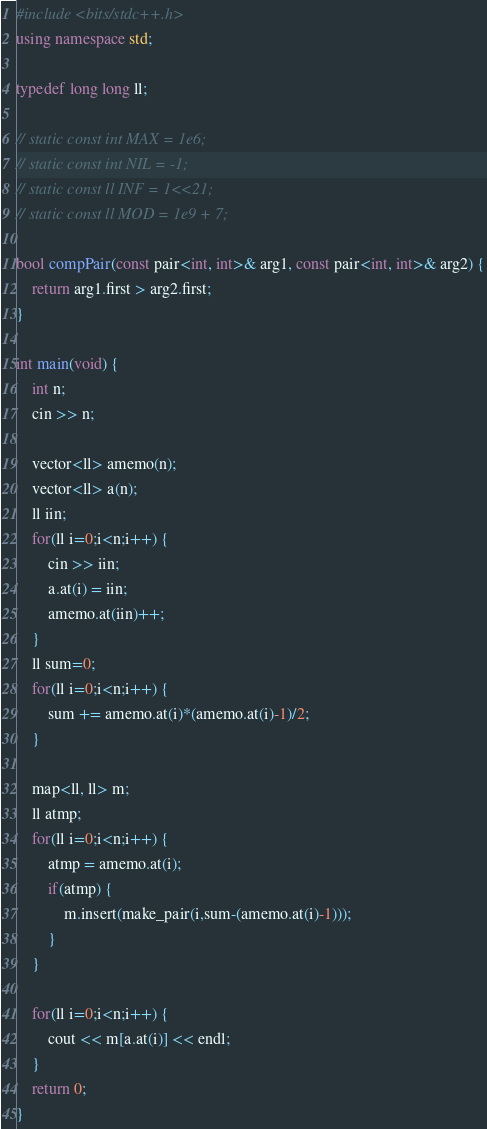<code> <loc_0><loc_0><loc_500><loc_500><_C++_>#include <bits/stdc++.h>
using namespace std;

typedef long long ll;

// static const int MAX = 1e6;
// static const int NIL = -1;
// static const ll INF = 1<<21;
// static const ll MOD = 1e9 + 7;

bool compPair(const pair<int, int>& arg1, const pair<int, int>& arg2) {
    return arg1.first > arg2.first;
}

int main(void) {
    int n;
    cin >> n;

    vector<ll> amemo(n);
    vector<ll> a(n);
    ll iin;
    for(ll i=0;i<n;i++) {
        cin >> iin;
        a.at(i) = iin;
        amemo.at(iin)++;
    }
    ll sum=0;
    for(ll i=0;i<n;i++) {
        sum += amemo.at(i)*(amemo.at(i)-1)/2;
    }

    map<ll, ll> m;
    ll atmp;
    for(ll i=0;i<n;i++) {
        atmp = amemo.at(i);
        if(atmp) {
            m.insert(make_pair(i,sum-(amemo.at(i)-1)));
        }
    }

    for(ll i=0;i<n;i++) {
        cout << m[a.at(i)] << endl;
    }
    return 0;
}
</code> 